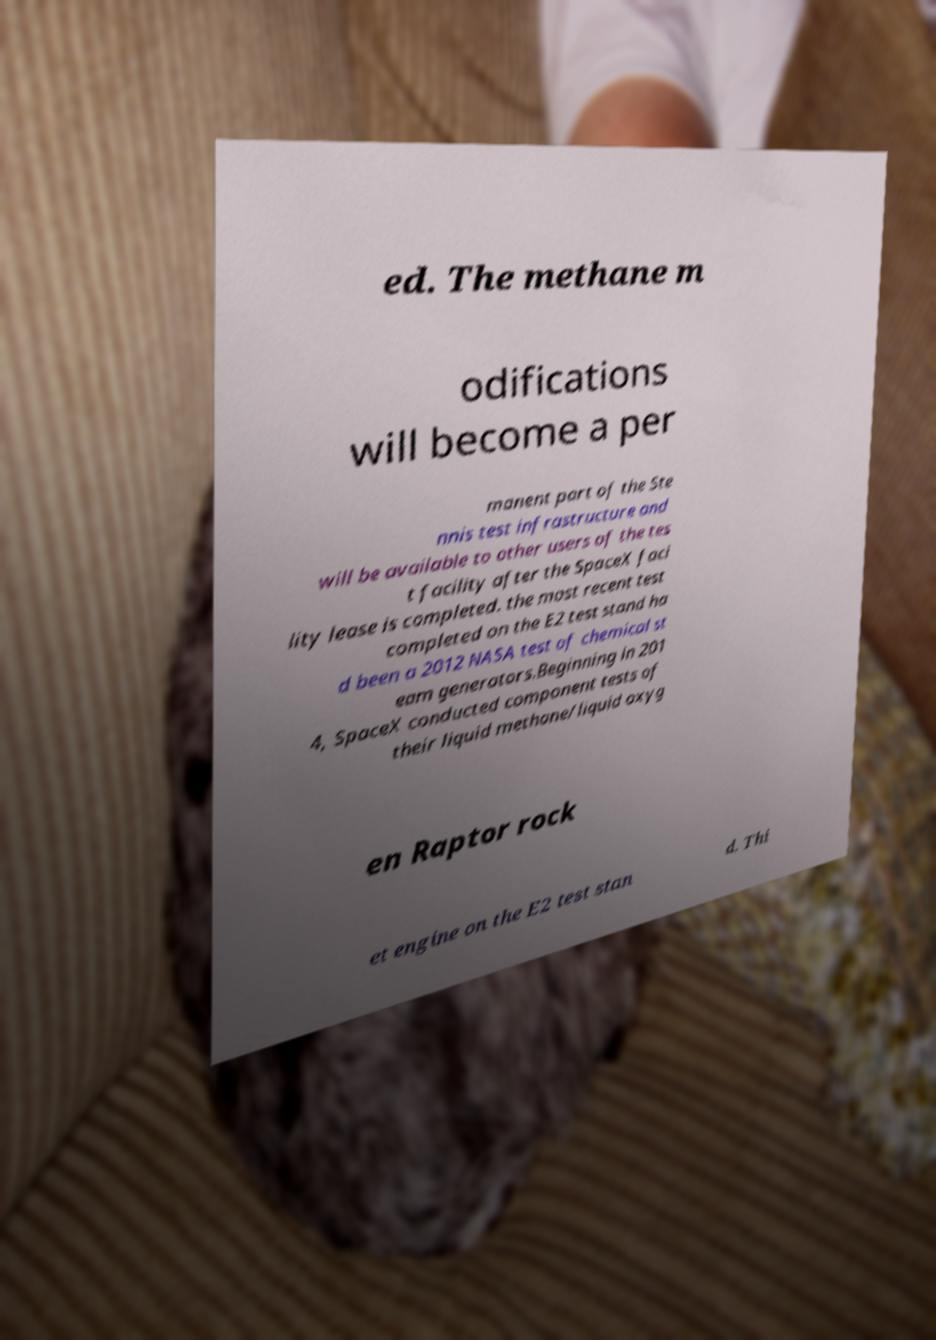There's text embedded in this image that I need extracted. Can you transcribe it verbatim? ed. The methane m odifications will become a per manent part of the Ste nnis test infrastructure and will be available to other users of the tes t facility after the SpaceX faci lity lease is completed. the most recent test completed on the E2 test stand ha d been a 2012 NASA test of chemical st eam generators.Beginning in 201 4, SpaceX conducted component tests of their liquid methane/liquid oxyg en Raptor rock et engine on the E2 test stan d. Thi 